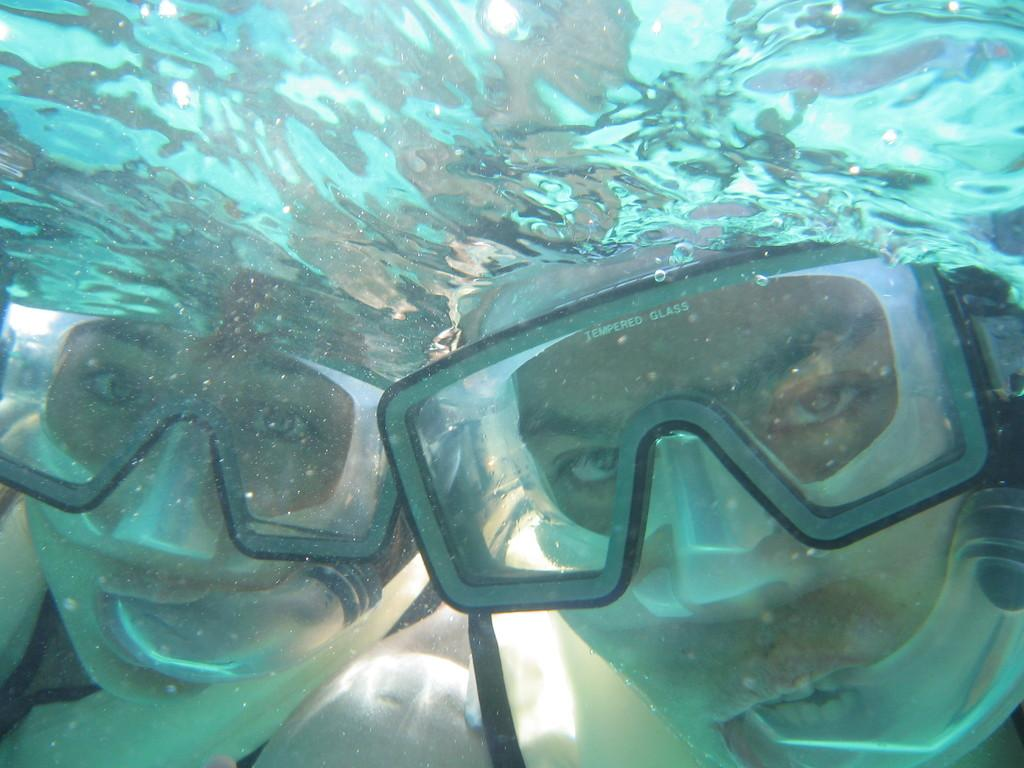How many people are in the image? There are two persons in the image. Where are the persons located in the image? The persons are underwater. What equipment might the persons be using for underwater activities? Swimming goggles are visible in the image. What type of wind can be seen blowing through the iron muscle in the image? There is no wind, iron, or muscle present in the image; it features two persons underwater. 